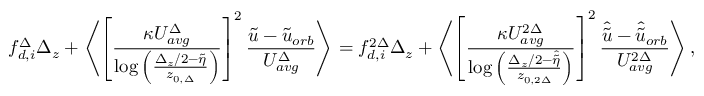Convert formula to latex. <formula><loc_0><loc_0><loc_500><loc_500>{ f _ { d , i } ^ { \Delta } } \Delta _ { z } + \left \langle \left [ \frac { \kappa U _ { a v g } ^ { \Delta } } { \log \left ( \frac { \Delta _ { z } / 2 - \widetilde { \eta } } { z _ { 0 , \Delta } } \right ) } \right ] ^ { 2 } \frac { \widetilde { u } - \widetilde { u } _ { o r b } } { U _ { a v g } ^ { \Delta } } \right \rangle = { f _ { d , i } ^ { 2 \Delta } } \Delta _ { z } + \left \langle \left [ \frac { \kappa U _ { a v g } ^ { 2 \Delta } } { \log \left ( \frac { \Delta _ { z } / 2 - \widehat { \widetilde { \eta } } } { z _ { 0 , 2 \Delta } } \right ) } \right ] ^ { 2 } \frac { \hat { \widetilde { u } } - \hat { \widetilde { u } } _ { o r b } } { U _ { a v g } ^ { 2 \Delta } } \right \rangle ,</formula> 